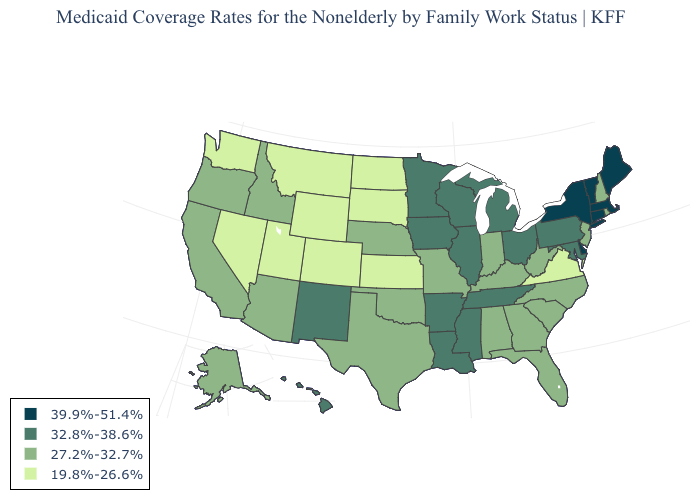Which states hav the highest value in the West?
Give a very brief answer. Hawaii, New Mexico. What is the value of Kansas?
Be succinct. 19.8%-26.6%. What is the lowest value in the USA?
Short answer required. 19.8%-26.6%. Among the states that border Nebraska , does South Dakota have the lowest value?
Concise answer only. Yes. What is the value of Virginia?
Keep it brief. 19.8%-26.6%. What is the value of Minnesota?
Give a very brief answer. 32.8%-38.6%. What is the highest value in the USA?
Quick response, please. 39.9%-51.4%. Name the states that have a value in the range 39.9%-51.4%?
Short answer required. Connecticut, Delaware, Maine, Massachusetts, New York, Vermont. How many symbols are there in the legend?
Give a very brief answer. 4. What is the value of Oklahoma?
Quick response, please. 27.2%-32.7%. Does Oklahoma have the highest value in the USA?
Concise answer only. No. What is the value of Alabama?
Answer briefly. 27.2%-32.7%. What is the value of Washington?
Answer briefly. 19.8%-26.6%. Does Virginia have the lowest value in the South?
Give a very brief answer. Yes. 